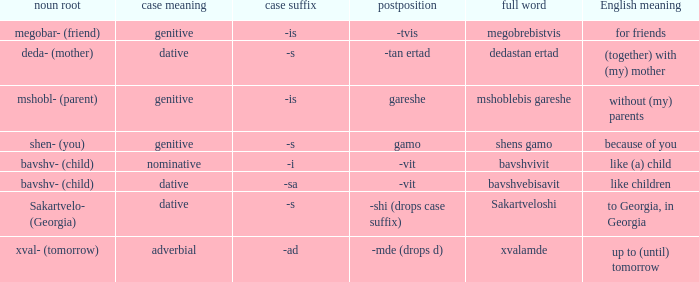What is Case Suffix (Case), when Postposition is "-mde (drops d)"? -ad (adverbial). 